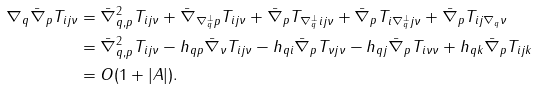<formula> <loc_0><loc_0><loc_500><loc_500>\nabla _ { q } \bar { \nabla } _ { p } T _ { i j \nu } & = \bar { \nabla } ^ { 2 } _ { q , p } T _ { i j \nu } + \bar { \nabla } _ { \nabla ^ { \perp } _ { q } p } T _ { i j \nu } + \bar { \nabla } _ { p } T _ { \nabla ^ { \perp } _ { q } i j \nu } + \bar { \nabla } _ { p } T _ { i \nabla ^ { \perp } _ { q } j \nu } + \bar { \nabla } _ { p } T _ { i j \nabla _ { q } \nu } \\ & = \bar { \nabla } ^ { 2 } _ { q , p } T _ { i j \nu } - h _ { q p } \bar { \nabla } _ { \nu } T _ { i j \nu } - h _ { q i } \bar { \nabla } _ { p } T _ { \nu j \nu } - h _ { q j } \bar { \nabla } _ { p } T _ { i \nu \nu } + h _ { q k } \bar { \nabla } _ { p } T _ { i j k } \\ & = O ( 1 + | A | ) .</formula> 